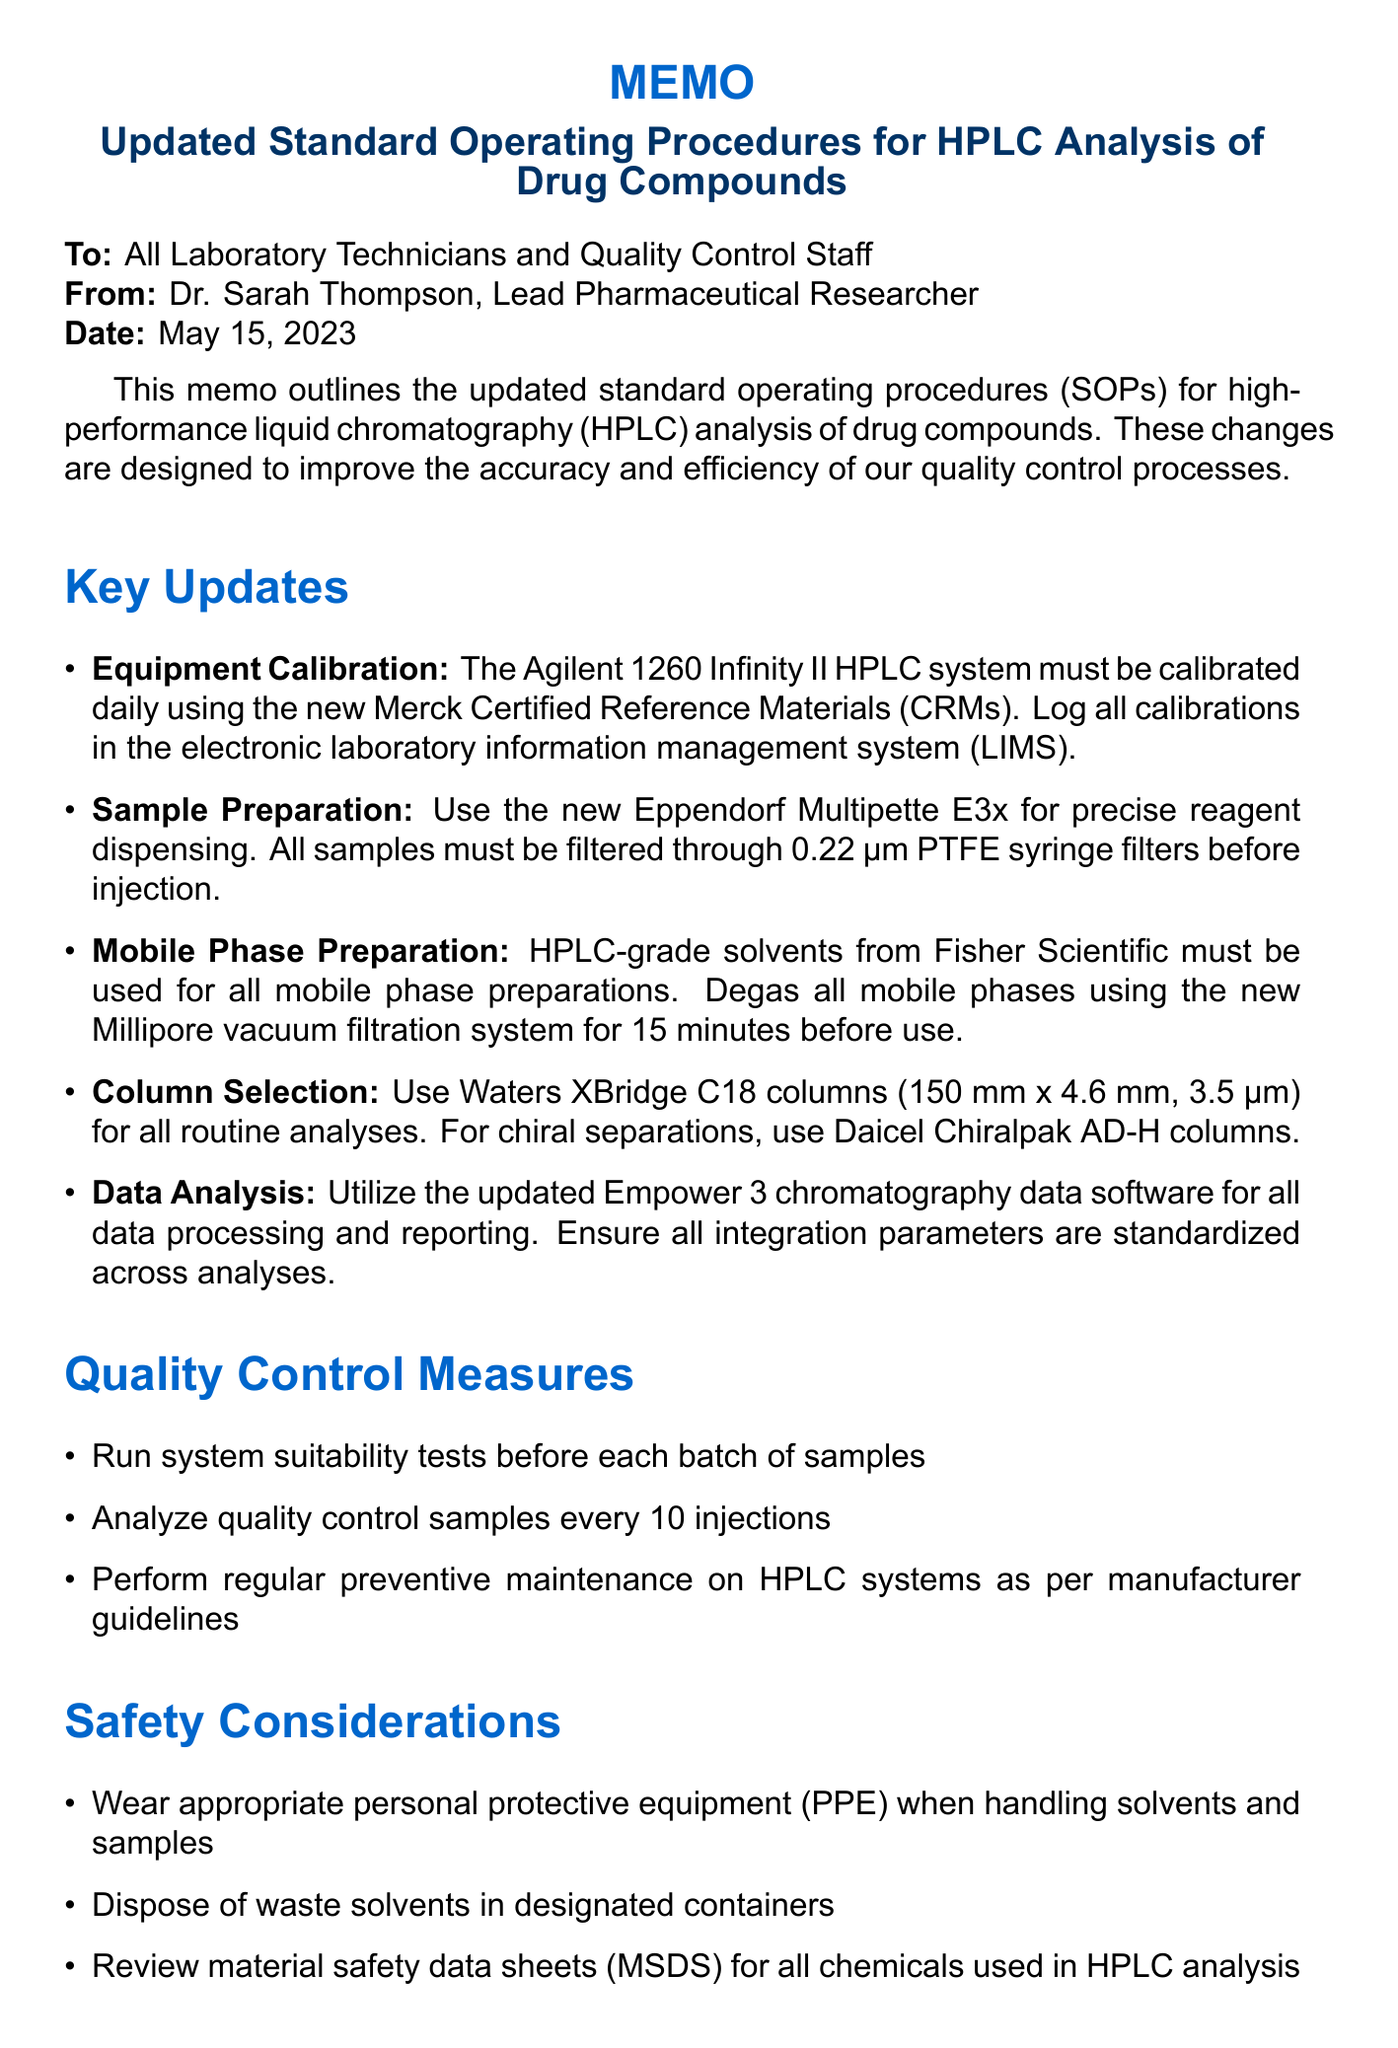What is the title of the memo? The title of the memo is mentioned at the top of the document as the subject of the memo.
Answer: Updated Standard Operating Procedures for HPLC Analysis of Drug Compounds Who is the sender of the memo? The sender of the memo is specified in the document, informing the recipients of who issued the communication.
Answer: Dr. Sarah Thompson, Lead Pharmaceutical Researcher When will the updated SOPs be effective? The effective date of the updated SOPs is given in the implementation timeline section, indicating when the changes take place.
Answer: June 1, 2023 What equipment must be calibrated daily? The memo specifies which HPLC system requires daily calibration for accurate measurements as per standard operating procedures.
Answer: Agilent 1260 Infinity II HPLC system What solvents must be used for mobile phase preparations? The document clearly states the required type of solvents for mobile phase preparations, indicating sourcing information.
Answer: HPLC-grade solvents from Fisher Scientific How often should quality control samples be analyzed? The memo indicates the frequency for analyzing quality control samples, providing a standard for laboratory practices.
Answer: Every 10 injections What is a training requirement for technicians? The memo outlines specific training that all technicians must undergo, emphasizing the importance of updated procedures.
Answer: Complete the updated HPLC training module on the Learning Management System What should be done before each batch of samples? The quality control measure highlighted in the document indicates a prerequisite step in the analytical process of drug compounds.
Answer: Run system suitability tests Who should be contacted for questions or clarifications? The document specifies the contact person for any inquiries regarding the memo, providing their details for easy reach.
Answer: Dr. Michael Chen, Quality Assurance Manager 